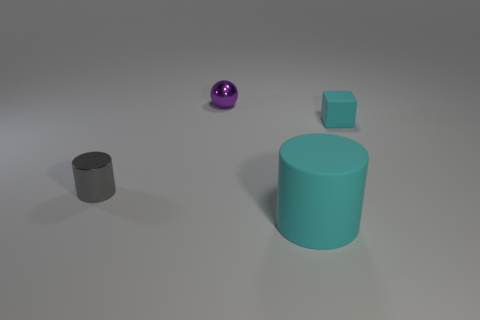What is the size of the sphere that is the same material as the small cylinder?
Give a very brief answer. Small. The thing that is the same color as the large cylinder is what size?
Provide a succinct answer. Small. How many other objects are there of the same size as the cyan cylinder?
Keep it short and to the point. 0. What is the material of the cyan object that is to the left of the cyan matte block?
Your response must be concise. Rubber. There is a tiny shiny thing left of the metallic object that is behind the rubber thing to the right of the cyan matte cylinder; what is its shape?
Offer a terse response. Cylinder. Does the rubber cube have the same size as the purple object?
Provide a short and direct response. Yes. What number of things are small rubber blocks or objects on the right side of the metallic cylinder?
Your answer should be very brief. 3. What number of things are either objects that are on the right side of the cyan cylinder or tiny cyan things that are in front of the tiny purple metal object?
Provide a succinct answer. 1. There is a cyan block; are there any tiny cyan matte blocks to the right of it?
Offer a very short reply. No. There is a metallic thing that is behind the small metal thing that is in front of the rubber thing behind the matte cylinder; what is its color?
Give a very brief answer. Purple. 